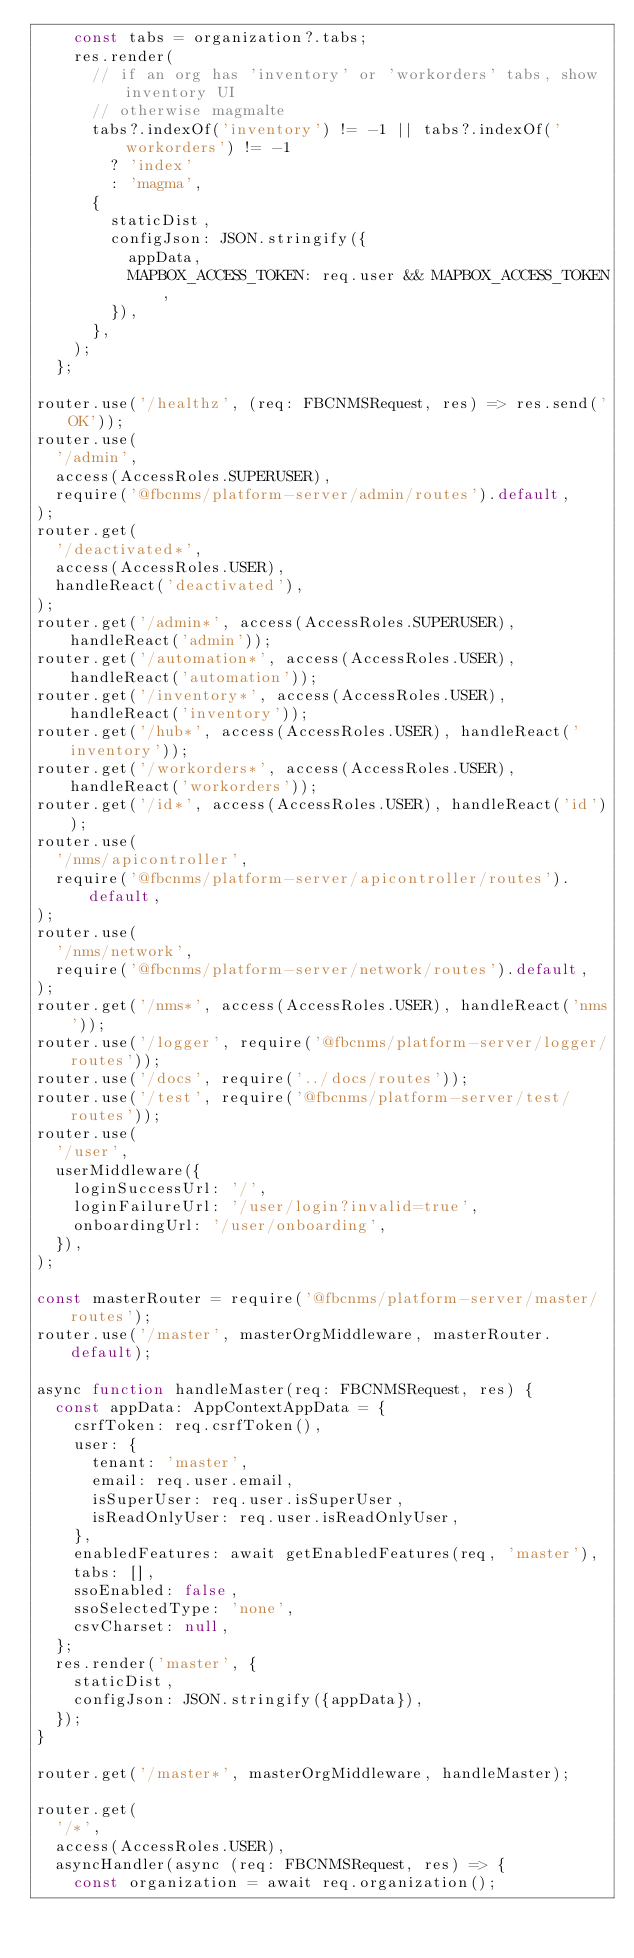Convert code to text. <code><loc_0><loc_0><loc_500><loc_500><_JavaScript_>    const tabs = organization?.tabs;
    res.render(
      // if an org has 'inventory' or 'workorders' tabs, show inventory UI
      // otherwise magmalte
      tabs?.indexOf('inventory') != -1 || tabs?.indexOf('workorders') != -1
        ? 'index'
        : 'magma',
      {
        staticDist,
        configJson: JSON.stringify({
          appData,
          MAPBOX_ACCESS_TOKEN: req.user && MAPBOX_ACCESS_TOKEN,
        }),
      },
    );
  };

router.use('/healthz', (req: FBCNMSRequest, res) => res.send('OK'));
router.use(
  '/admin',
  access(AccessRoles.SUPERUSER),
  require('@fbcnms/platform-server/admin/routes').default,
);
router.get(
  '/deactivated*',
  access(AccessRoles.USER),
  handleReact('deactivated'),
);
router.get('/admin*', access(AccessRoles.SUPERUSER), handleReact('admin'));
router.get('/automation*', access(AccessRoles.USER), handleReact('automation'));
router.get('/inventory*', access(AccessRoles.USER), handleReact('inventory'));
router.get('/hub*', access(AccessRoles.USER), handleReact('inventory'));
router.get('/workorders*', access(AccessRoles.USER), handleReact('workorders'));
router.get('/id*', access(AccessRoles.USER), handleReact('id'));
router.use(
  '/nms/apicontroller',
  require('@fbcnms/platform-server/apicontroller/routes').default,
);
router.use(
  '/nms/network',
  require('@fbcnms/platform-server/network/routes').default,
);
router.get('/nms*', access(AccessRoles.USER), handleReact('nms'));
router.use('/logger', require('@fbcnms/platform-server/logger/routes'));
router.use('/docs', require('../docs/routes'));
router.use('/test', require('@fbcnms/platform-server/test/routes'));
router.use(
  '/user',
  userMiddleware({
    loginSuccessUrl: '/',
    loginFailureUrl: '/user/login?invalid=true',
    onboardingUrl: '/user/onboarding',
  }),
);

const masterRouter = require('@fbcnms/platform-server/master/routes');
router.use('/master', masterOrgMiddleware, masterRouter.default);

async function handleMaster(req: FBCNMSRequest, res) {
  const appData: AppContextAppData = {
    csrfToken: req.csrfToken(),
    user: {
      tenant: 'master',
      email: req.user.email,
      isSuperUser: req.user.isSuperUser,
      isReadOnlyUser: req.user.isReadOnlyUser,
    },
    enabledFeatures: await getEnabledFeatures(req, 'master'),
    tabs: [],
    ssoEnabled: false,
    ssoSelectedType: 'none',
    csvCharset: null,
  };
  res.render('master', {
    staticDist,
    configJson: JSON.stringify({appData}),
  });
}

router.get('/master*', masterOrgMiddleware, handleMaster);

router.get(
  '/*',
  access(AccessRoles.USER),
  asyncHandler(async (req: FBCNMSRequest, res) => {
    const organization = await req.organization();</code> 